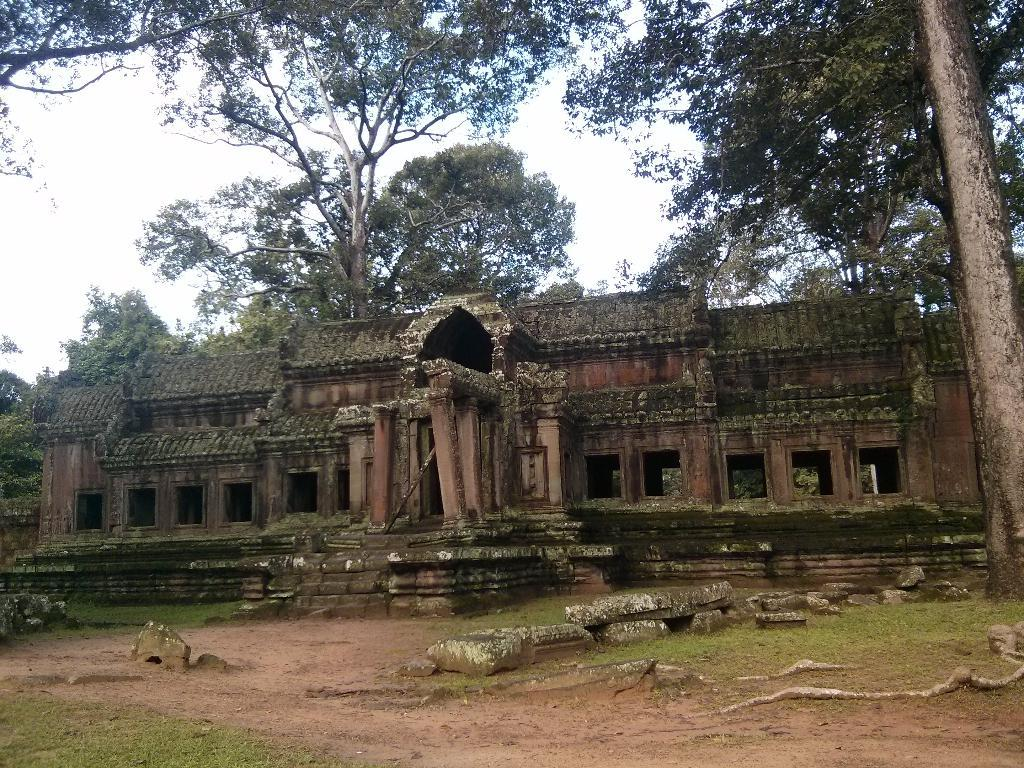What type of vegetation can be seen in the image? There is grass in the image. What type of structure is present in the image? There is an old building in the image. What other natural elements can be seen in the image? There are trees in the image. What is visible at the top of the image? The sky is visible at the top of the image. Can you tell me how many ears are visible on the old building in the image? There are no ears present on the old building in the image; it is a structure and not a living being. Is there a pet visible in the image? There is no pet present in the image. 